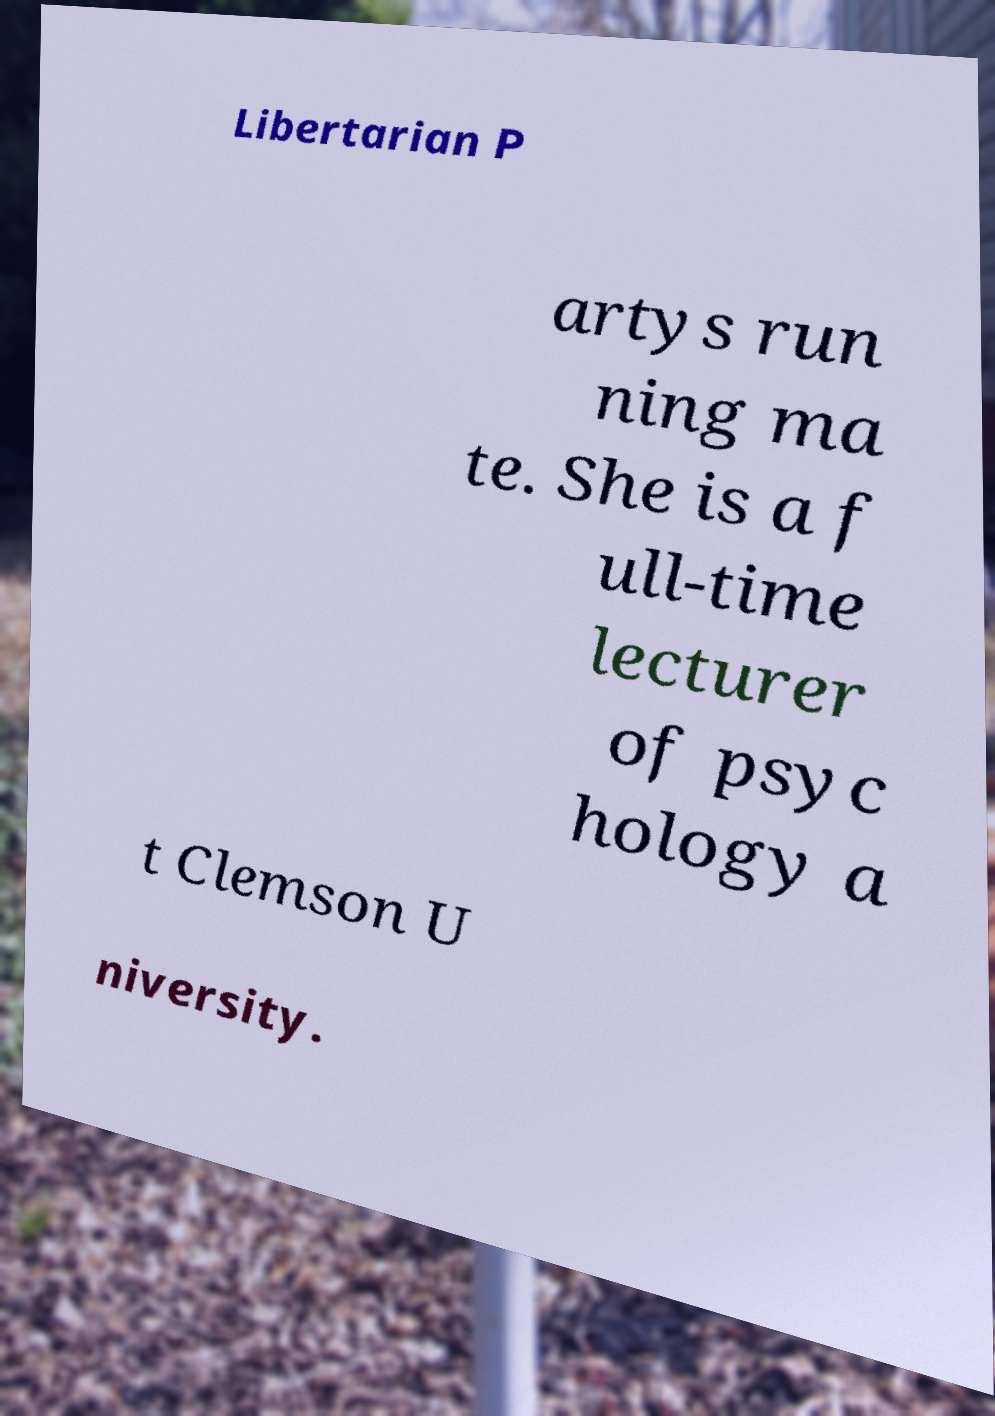Can you accurately transcribe the text from the provided image for me? Libertarian P artys run ning ma te. She is a f ull-time lecturer of psyc hology a t Clemson U niversity. 